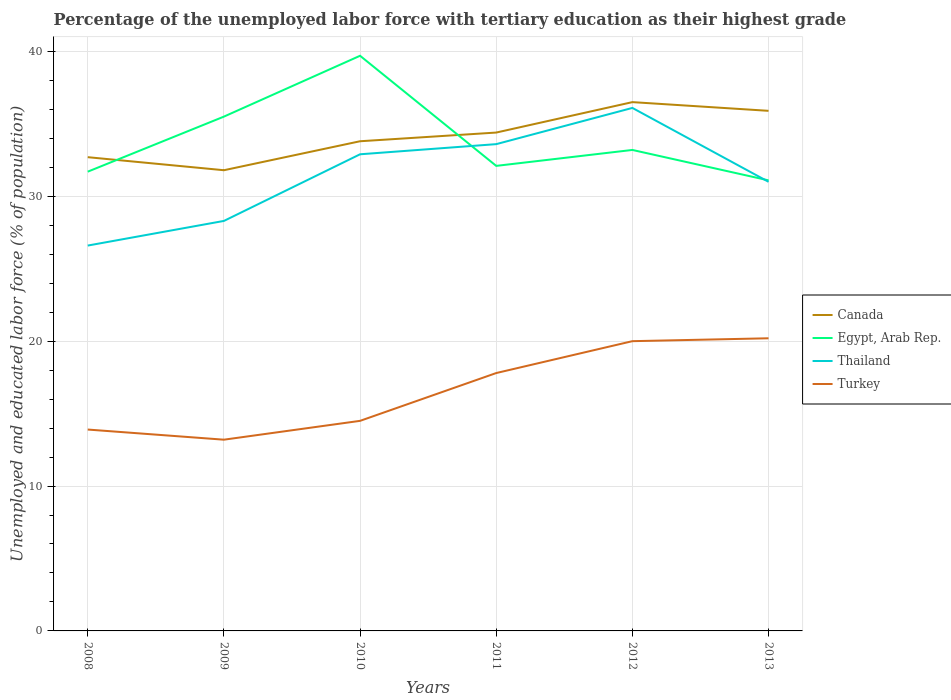How many different coloured lines are there?
Make the answer very short. 4. Across all years, what is the maximum percentage of the unemployed labor force with tertiary education in Thailand?
Give a very brief answer. 26.6. What is the total percentage of the unemployed labor force with tertiary education in Egypt, Arab Rep. in the graph?
Offer a terse response. 2.3. What is the difference between the highest and the second highest percentage of the unemployed labor force with tertiary education in Turkey?
Your answer should be very brief. 7. What is the difference between the highest and the lowest percentage of the unemployed labor force with tertiary education in Canada?
Your answer should be compact. 3. How many years are there in the graph?
Your answer should be compact. 6. What is the difference between two consecutive major ticks on the Y-axis?
Offer a terse response. 10. Are the values on the major ticks of Y-axis written in scientific E-notation?
Your answer should be compact. No. Where does the legend appear in the graph?
Offer a terse response. Center right. How many legend labels are there?
Keep it short and to the point. 4. What is the title of the graph?
Ensure brevity in your answer.  Percentage of the unemployed labor force with tertiary education as their highest grade. Does "Australia" appear as one of the legend labels in the graph?
Give a very brief answer. No. What is the label or title of the Y-axis?
Provide a short and direct response. Unemployed and educated labor force (% of population). What is the Unemployed and educated labor force (% of population) in Canada in 2008?
Provide a succinct answer. 32.7. What is the Unemployed and educated labor force (% of population) of Egypt, Arab Rep. in 2008?
Keep it short and to the point. 31.7. What is the Unemployed and educated labor force (% of population) in Thailand in 2008?
Make the answer very short. 26.6. What is the Unemployed and educated labor force (% of population) of Turkey in 2008?
Offer a terse response. 13.9. What is the Unemployed and educated labor force (% of population) in Canada in 2009?
Provide a succinct answer. 31.8. What is the Unemployed and educated labor force (% of population) of Egypt, Arab Rep. in 2009?
Your answer should be compact. 35.5. What is the Unemployed and educated labor force (% of population) of Thailand in 2009?
Offer a terse response. 28.3. What is the Unemployed and educated labor force (% of population) in Turkey in 2009?
Provide a succinct answer. 13.2. What is the Unemployed and educated labor force (% of population) of Canada in 2010?
Ensure brevity in your answer.  33.8. What is the Unemployed and educated labor force (% of population) of Egypt, Arab Rep. in 2010?
Offer a terse response. 39.7. What is the Unemployed and educated labor force (% of population) in Thailand in 2010?
Provide a succinct answer. 32.9. What is the Unemployed and educated labor force (% of population) in Turkey in 2010?
Your answer should be compact. 14.5. What is the Unemployed and educated labor force (% of population) in Canada in 2011?
Your answer should be very brief. 34.4. What is the Unemployed and educated labor force (% of population) in Egypt, Arab Rep. in 2011?
Keep it short and to the point. 32.1. What is the Unemployed and educated labor force (% of population) of Thailand in 2011?
Make the answer very short. 33.6. What is the Unemployed and educated labor force (% of population) of Turkey in 2011?
Keep it short and to the point. 17.8. What is the Unemployed and educated labor force (% of population) of Canada in 2012?
Make the answer very short. 36.5. What is the Unemployed and educated labor force (% of population) of Egypt, Arab Rep. in 2012?
Offer a very short reply. 33.2. What is the Unemployed and educated labor force (% of population) in Thailand in 2012?
Offer a very short reply. 36.1. What is the Unemployed and educated labor force (% of population) of Turkey in 2012?
Offer a terse response. 20. What is the Unemployed and educated labor force (% of population) in Canada in 2013?
Offer a terse response. 35.9. What is the Unemployed and educated labor force (% of population) of Egypt, Arab Rep. in 2013?
Your response must be concise. 31.1. What is the Unemployed and educated labor force (% of population) of Turkey in 2013?
Ensure brevity in your answer.  20.2. Across all years, what is the maximum Unemployed and educated labor force (% of population) in Canada?
Your answer should be very brief. 36.5. Across all years, what is the maximum Unemployed and educated labor force (% of population) in Egypt, Arab Rep.?
Your answer should be very brief. 39.7. Across all years, what is the maximum Unemployed and educated labor force (% of population) in Thailand?
Your answer should be compact. 36.1. Across all years, what is the maximum Unemployed and educated labor force (% of population) in Turkey?
Provide a short and direct response. 20.2. Across all years, what is the minimum Unemployed and educated labor force (% of population) of Canada?
Provide a short and direct response. 31.8. Across all years, what is the minimum Unemployed and educated labor force (% of population) of Egypt, Arab Rep.?
Keep it short and to the point. 31.1. Across all years, what is the minimum Unemployed and educated labor force (% of population) of Thailand?
Provide a short and direct response. 26.6. Across all years, what is the minimum Unemployed and educated labor force (% of population) of Turkey?
Keep it short and to the point. 13.2. What is the total Unemployed and educated labor force (% of population) of Canada in the graph?
Provide a short and direct response. 205.1. What is the total Unemployed and educated labor force (% of population) in Egypt, Arab Rep. in the graph?
Offer a very short reply. 203.3. What is the total Unemployed and educated labor force (% of population) in Thailand in the graph?
Keep it short and to the point. 188.5. What is the total Unemployed and educated labor force (% of population) of Turkey in the graph?
Offer a very short reply. 99.6. What is the difference between the Unemployed and educated labor force (% of population) of Egypt, Arab Rep. in 2008 and that in 2009?
Keep it short and to the point. -3.8. What is the difference between the Unemployed and educated labor force (% of population) in Canada in 2008 and that in 2010?
Provide a short and direct response. -1.1. What is the difference between the Unemployed and educated labor force (% of population) in Egypt, Arab Rep. in 2008 and that in 2010?
Offer a terse response. -8. What is the difference between the Unemployed and educated labor force (% of population) of Thailand in 2008 and that in 2010?
Your answer should be compact. -6.3. What is the difference between the Unemployed and educated labor force (% of population) in Canada in 2008 and that in 2011?
Your answer should be compact. -1.7. What is the difference between the Unemployed and educated labor force (% of population) of Thailand in 2008 and that in 2011?
Provide a short and direct response. -7. What is the difference between the Unemployed and educated labor force (% of population) in Canada in 2008 and that in 2012?
Give a very brief answer. -3.8. What is the difference between the Unemployed and educated labor force (% of population) in Egypt, Arab Rep. in 2008 and that in 2012?
Your response must be concise. -1.5. What is the difference between the Unemployed and educated labor force (% of population) in Thailand in 2008 and that in 2012?
Ensure brevity in your answer.  -9.5. What is the difference between the Unemployed and educated labor force (% of population) of Turkey in 2008 and that in 2012?
Your answer should be compact. -6.1. What is the difference between the Unemployed and educated labor force (% of population) of Egypt, Arab Rep. in 2008 and that in 2013?
Give a very brief answer. 0.6. What is the difference between the Unemployed and educated labor force (% of population) of Thailand in 2008 and that in 2013?
Provide a succinct answer. -4.4. What is the difference between the Unemployed and educated labor force (% of population) in Canada in 2009 and that in 2010?
Make the answer very short. -2. What is the difference between the Unemployed and educated labor force (% of population) of Egypt, Arab Rep. in 2009 and that in 2010?
Make the answer very short. -4.2. What is the difference between the Unemployed and educated labor force (% of population) of Thailand in 2009 and that in 2010?
Your answer should be very brief. -4.6. What is the difference between the Unemployed and educated labor force (% of population) in Egypt, Arab Rep. in 2009 and that in 2011?
Provide a short and direct response. 3.4. What is the difference between the Unemployed and educated labor force (% of population) of Egypt, Arab Rep. in 2009 and that in 2012?
Ensure brevity in your answer.  2.3. What is the difference between the Unemployed and educated labor force (% of population) of Thailand in 2009 and that in 2012?
Provide a short and direct response. -7.8. What is the difference between the Unemployed and educated labor force (% of population) of Canada in 2009 and that in 2013?
Provide a succinct answer. -4.1. What is the difference between the Unemployed and educated labor force (% of population) of Egypt, Arab Rep. in 2009 and that in 2013?
Ensure brevity in your answer.  4.4. What is the difference between the Unemployed and educated labor force (% of population) of Thailand in 2009 and that in 2013?
Your answer should be very brief. -2.7. What is the difference between the Unemployed and educated labor force (% of population) of Canada in 2010 and that in 2011?
Your answer should be very brief. -0.6. What is the difference between the Unemployed and educated labor force (% of population) of Thailand in 2010 and that in 2011?
Your answer should be compact. -0.7. What is the difference between the Unemployed and educated labor force (% of population) of Canada in 2010 and that in 2012?
Keep it short and to the point. -2.7. What is the difference between the Unemployed and educated labor force (% of population) of Egypt, Arab Rep. in 2010 and that in 2012?
Provide a short and direct response. 6.5. What is the difference between the Unemployed and educated labor force (% of population) in Thailand in 2010 and that in 2012?
Make the answer very short. -3.2. What is the difference between the Unemployed and educated labor force (% of population) in Egypt, Arab Rep. in 2010 and that in 2013?
Make the answer very short. 8.6. What is the difference between the Unemployed and educated labor force (% of population) in Thailand in 2010 and that in 2013?
Your answer should be compact. 1.9. What is the difference between the Unemployed and educated labor force (% of population) in Turkey in 2010 and that in 2013?
Ensure brevity in your answer.  -5.7. What is the difference between the Unemployed and educated labor force (% of population) in Egypt, Arab Rep. in 2011 and that in 2012?
Give a very brief answer. -1.1. What is the difference between the Unemployed and educated labor force (% of population) in Canada in 2011 and that in 2013?
Offer a very short reply. -1.5. What is the difference between the Unemployed and educated labor force (% of population) in Egypt, Arab Rep. in 2011 and that in 2013?
Provide a short and direct response. 1. What is the difference between the Unemployed and educated labor force (% of population) of Thailand in 2011 and that in 2013?
Offer a terse response. 2.6. What is the difference between the Unemployed and educated labor force (% of population) in Turkey in 2011 and that in 2013?
Your answer should be very brief. -2.4. What is the difference between the Unemployed and educated labor force (% of population) in Canada in 2012 and that in 2013?
Make the answer very short. 0.6. What is the difference between the Unemployed and educated labor force (% of population) of Thailand in 2012 and that in 2013?
Your response must be concise. 5.1. What is the difference between the Unemployed and educated labor force (% of population) in Canada in 2008 and the Unemployed and educated labor force (% of population) in Thailand in 2009?
Ensure brevity in your answer.  4.4. What is the difference between the Unemployed and educated labor force (% of population) of Canada in 2008 and the Unemployed and educated labor force (% of population) of Turkey in 2009?
Your response must be concise. 19.5. What is the difference between the Unemployed and educated labor force (% of population) in Egypt, Arab Rep. in 2008 and the Unemployed and educated labor force (% of population) in Thailand in 2009?
Offer a terse response. 3.4. What is the difference between the Unemployed and educated labor force (% of population) of Egypt, Arab Rep. in 2008 and the Unemployed and educated labor force (% of population) of Turkey in 2009?
Provide a succinct answer. 18.5. What is the difference between the Unemployed and educated labor force (% of population) of Thailand in 2008 and the Unemployed and educated labor force (% of population) of Turkey in 2009?
Your answer should be very brief. 13.4. What is the difference between the Unemployed and educated labor force (% of population) of Canada in 2008 and the Unemployed and educated labor force (% of population) of Thailand in 2010?
Offer a very short reply. -0.2. What is the difference between the Unemployed and educated labor force (% of population) in Canada in 2008 and the Unemployed and educated labor force (% of population) in Turkey in 2010?
Provide a succinct answer. 18.2. What is the difference between the Unemployed and educated labor force (% of population) in Egypt, Arab Rep. in 2008 and the Unemployed and educated labor force (% of population) in Thailand in 2010?
Your answer should be very brief. -1.2. What is the difference between the Unemployed and educated labor force (% of population) in Canada in 2008 and the Unemployed and educated labor force (% of population) in Turkey in 2011?
Make the answer very short. 14.9. What is the difference between the Unemployed and educated labor force (% of population) of Egypt, Arab Rep. in 2008 and the Unemployed and educated labor force (% of population) of Thailand in 2011?
Offer a terse response. -1.9. What is the difference between the Unemployed and educated labor force (% of population) of Canada in 2008 and the Unemployed and educated labor force (% of population) of Thailand in 2012?
Provide a short and direct response. -3.4. What is the difference between the Unemployed and educated labor force (% of population) of Canada in 2008 and the Unemployed and educated labor force (% of population) of Turkey in 2012?
Offer a terse response. 12.7. What is the difference between the Unemployed and educated labor force (% of population) in Egypt, Arab Rep. in 2008 and the Unemployed and educated labor force (% of population) in Thailand in 2012?
Offer a very short reply. -4.4. What is the difference between the Unemployed and educated labor force (% of population) in Egypt, Arab Rep. in 2008 and the Unemployed and educated labor force (% of population) in Turkey in 2012?
Your answer should be compact. 11.7. What is the difference between the Unemployed and educated labor force (% of population) in Thailand in 2008 and the Unemployed and educated labor force (% of population) in Turkey in 2012?
Make the answer very short. 6.6. What is the difference between the Unemployed and educated labor force (% of population) of Thailand in 2008 and the Unemployed and educated labor force (% of population) of Turkey in 2013?
Make the answer very short. 6.4. What is the difference between the Unemployed and educated labor force (% of population) of Canada in 2009 and the Unemployed and educated labor force (% of population) of Turkey in 2010?
Ensure brevity in your answer.  17.3. What is the difference between the Unemployed and educated labor force (% of population) in Thailand in 2009 and the Unemployed and educated labor force (% of population) in Turkey in 2010?
Offer a very short reply. 13.8. What is the difference between the Unemployed and educated labor force (% of population) in Canada in 2009 and the Unemployed and educated labor force (% of population) in Egypt, Arab Rep. in 2011?
Your response must be concise. -0.3. What is the difference between the Unemployed and educated labor force (% of population) in Canada in 2009 and the Unemployed and educated labor force (% of population) in Thailand in 2011?
Offer a terse response. -1.8. What is the difference between the Unemployed and educated labor force (% of population) in Egypt, Arab Rep. in 2009 and the Unemployed and educated labor force (% of population) in Turkey in 2011?
Keep it short and to the point. 17.7. What is the difference between the Unemployed and educated labor force (% of population) of Canada in 2009 and the Unemployed and educated labor force (% of population) of Thailand in 2013?
Your answer should be very brief. 0.8. What is the difference between the Unemployed and educated labor force (% of population) of Canada in 2009 and the Unemployed and educated labor force (% of population) of Turkey in 2013?
Your response must be concise. 11.6. What is the difference between the Unemployed and educated labor force (% of population) in Egypt, Arab Rep. in 2009 and the Unemployed and educated labor force (% of population) in Thailand in 2013?
Your response must be concise. 4.5. What is the difference between the Unemployed and educated labor force (% of population) in Egypt, Arab Rep. in 2009 and the Unemployed and educated labor force (% of population) in Turkey in 2013?
Your answer should be very brief. 15.3. What is the difference between the Unemployed and educated labor force (% of population) of Thailand in 2009 and the Unemployed and educated labor force (% of population) of Turkey in 2013?
Give a very brief answer. 8.1. What is the difference between the Unemployed and educated labor force (% of population) of Egypt, Arab Rep. in 2010 and the Unemployed and educated labor force (% of population) of Thailand in 2011?
Offer a terse response. 6.1. What is the difference between the Unemployed and educated labor force (% of population) in Egypt, Arab Rep. in 2010 and the Unemployed and educated labor force (% of population) in Turkey in 2011?
Ensure brevity in your answer.  21.9. What is the difference between the Unemployed and educated labor force (% of population) of Thailand in 2010 and the Unemployed and educated labor force (% of population) of Turkey in 2011?
Provide a short and direct response. 15.1. What is the difference between the Unemployed and educated labor force (% of population) in Canada in 2010 and the Unemployed and educated labor force (% of population) in Thailand in 2012?
Provide a short and direct response. -2.3. What is the difference between the Unemployed and educated labor force (% of population) of Canada in 2010 and the Unemployed and educated labor force (% of population) of Turkey in 2012?
Make the answer very short. 13.8. What is the difference between the Unemployed and educated labor force (% of population) in Egypt, Arab Rep. in 2010 and the Unemployed and educated labor force (% of population) in Thailand in 2012?
Your response must be concise. 3.6. What is the difference between the Unemployed and educated labor force (% of population) of Thailand in 2010 and the Unemployed and educated labor force (% of population) of Turkey in 2012?
Keep it short and to the point. 12.9. What is the difference between the Unemployed and educated labor force (% of population) in Canada in 2010 and the Unemployed and educated labor force (% of population) in Thailand in 2013?
Provide a short and direct response. 2.8. What is the difference between the Unemployed and educated labor force (% of population) in Egypt, Arab Rep. in 2010 and the Unemployed and educated labor force (% of population) in Turkey in 2013?
Offer a very short reply. 19.5. What is the difference between the Unemployed and educated labor force (% of population) of Thailand in 2010 and the Unemployed and educated labor force (% of population) of Turkey in 2013?
Make the answer very short. 12.7. What is the difference between the Unemployed and educated labor force (% of population) in Canada in 2011 and the Unemployed and educated labor force (% of population) in Turkey in 2012?
Ensure brevity in your answer.  14.4. What is the difference between the Unemployed and educated labor force (% of population) of Egypt, Arab Rep. in 2011 and the Unemployed and educated labor force (% of population) of Thailand in 2012?
Offer a very short reply. -4. What is the difference between the Unemployed and educated labor force (% of population) of Thailand in 2011 and the Unemployed and educated labor force (% of population) of Turkey in 2012?
Make the answer very short. 13.6. What is the difference between the Unemployed and educated labor force (% of population) in Canada in 2011 and the Unemployed and educated labor force (% of population) in Egypt, Arab Rep. in 2013?
Make the answer very short. 3.3. What is the difference between the Unemployed and educated labor force (% of population) in Canada in 2011 and the Unemployed and educated labor force (% of population) in Turkey in 2013?
Provide a succinct answer. 14.2. What is the difference between the Unemployed and educated labor force (% of population) in Egypt, Arab Rep. in 2011 and the Unemployed and educated labor force (% of population) in Thailand in 2013?
Offer a terse response. 1.1. What is the difference between the Unemployed and educated labor force (% of population) in Egypt, Arab Rep. in 2011 and the Unemployed and educated labor force (% of population) in Turkey in 2013?
Offer a terse response. 11.9. What is the difference between the Unemployed and educated labor force (% of population) of Egypt, Arab Rep. in 2012 and the Unemployed and educated labor force (% of population) of Thailand in 2013?
Provide a succinct answer. 2.2. What is the difference between the Unemployed and educated labor force (% of population) of Thailand in 2012 and the Unemployed and educated labor force (% of population) of Turkey in 2013?
Keep it short and to the point. 15.9. What is the average Unemployed and educated labor force (% of population) of Canada per year?
Your response must be concise. 34.18. What is the average Unemployed and educated labor force (% of population) in Egypt, Arab Rep. per year?
Your answer should be compact. 33.88. What is the average Unemployed and educated labor force (% of population) of Thailand per year?
Offer a very short reply. 31.42. What is the average Unemployed and educated labor force (% of population) of Turkey per year?
Make the answer very short. 16.6. In the year 2008, what is the difference between the Unemployed and educated labor force (% of population) in Canada and Unemployed and educated labor force (% of population) in Egypt, Arab Rep.?
Make the answer very short. 1. In the year 2008, what is the difference between the Unemployed and educated labor force (% of population) in Egypt, Arab Rep. and Unemployed and educated labor force (% of population) in Thailand?
Your answer should be very brief. 5.1. In the year 2008, what is the difference between the Unemployed and educated labor force (% of population) of Thailand and Unemployed and educated labor force (% of population) of Turkey?
Make the answer very short. 12.7. In the year 2009, what is the difference between the Unemployed and educated labor force (% of population) in Canada and Unemployed and educated labor force (% of population) in Turkey?
Make the answer very short. 18.6. In the year 2009, what is the difference between the Unemployed and educated labor force (% of population) of Egypt, Arab Rep. and Unemployed and educated labor force (% of population) of Turkey?
Your answer should be very brief. 22.3. In the year 2010, what is the difference between the Unemployed and educated labor force (% of population) in Canada and Unemployed and educated labor force (% of population) in Turkey?
Make the answer very short. 19.3. In the year 2010, what is the difference between the Unemployed and educated labor force (% of population) in Egypt, Arab Rep. and Unemployed and educated labor force (% of population) in Thailand?
Make the answer very short. 6.8. In the year 2010, what is the difference between the Unemployed and educated labor force (% of population) of Egypt, Arab Rep. and Unemployed and educated labor force (% of population) of Turkey?
Give a very brief answer. 25.2. In the year 2011, what is the difference between the Unemployed and educated labor force (% of population) in Canada and Unemployed and educated labor force (% of population) in Egypt, Arab Rep.?
Your response must be concise. 2.3. In the year 2011, what is the difference between the Unemployed and educated labor force (% of population) of Egypt, Arab Rep. and Unemployed and educated labor force (% of population) of Turkey?
Your answer should be very brief. 14.3. In the year 2012, what is the difference between the Unemployed and educated labor force (% of population) of Canada and Unemployed and educated labor force (% of population) of Thailand?
Make the answer very short. 0.4. In the year 2012, what is the difference between the Unemployed and educated labor force (% of population) in Canada and Unemployed and educated labor force (% of population) in Turkey?
Your answer should be compact. 16.5. In the year 2012, what is the difference between the Unemployed and educated labor force (% of population) of Egypt, Arab Rep. and Unemployed and educated labor force (% of population) of Thailand?
Provide a succinct answer. -2.9. In the year 2013, what is the difference between the Unemployed and educated labor force (% of population) in Canada and Unemployed and educated labor force (% of population) in Egypt, Arab Rep.?
Your answer should be compact. 4.8. In the year 2013, what is the difference between the Unemployed and educated labor force (% of population) of Egypt, Arab Rep. and Unemployed and educated labor force (% of population) of Turkey?
Provide a short and direct response. 10.9. What is the ratio of the Unemployed and educated labor force (% of population) in Canada in 2008 to that in 2009?
Make the answer very short. 1.03. What is the ratio of the Unemployed and educated labor force (% of population) of Egypt, Arab Rep. in 2008 to that in 2009?
Make the answer very short. 0.89. What is the ratio of the Unemployed and educated labor force (% of population) in Thailand in 2008 to that in 2009?
Ensure brevity in your answer.  0.94. What is the ratio of the Unemployed and educated labor force (% of population) of Turkey in 2008 to that in 2009?
Your response must be concise. 1.05. What is the ratio of the Unemployed and educated labor force (% of population) of Canada in 2008 to that in 2010?
Offer a terse response. 0.97. What is the ratio of the Unemployed and educated labor force (% of population) in Egypt, Arab Rep. in 2008 to that in 2010?
Offer a very short reply. 0.8. What is the ratio of the Unemployed and educated labor force (% of population) of Thailand in 2008 to that in 2010?
Your answer should be very brief. 0.81. What is the ratio of the Unemployed and educated labor force (% of population) in Turkey in 2008 to that in 2010?
Offer a terse response. 0.96. What is the ratio of the Unemployed and educated labor force (% of population) of Canada in 2008 to that in 2011?
Offer a terse response. 0.95. What is the ratio of the Unemployed and educated labor force (% of population) in Egypt, Arab Rep. in 2008 to that in 2011?
Your answer should be compact. 0.99. What is the ratio of the Unemployed and educated labor force (% of population) of Thailand in 2008 to that in 2011?
Provide a short and direct response. 0.79. What is the ratio of the Unemployed and educated labor force (% of population) in Turkey in 2008 to that in 2011?
Ensure brevity in your answer.  0.78. What is the ratio of the Unemployed and educated labor force (% of population) in Canada in 2008 to that in 2012?
Your answer should be compact. 0.9. What is the ratio of the Unemployed and educated labor force (% of population) of Egypt, Arab Rep. in 2008 to that in 2012?
Your answer should be very brief. 0.95. What is the ratio of the Unemployed and educated labor force (% of population) of Thailand in 2008 to that in 2012?
Keep it short and to the point. 0.74. What is the ratio of the Unemployed and educated labor force (% of population) of Turkey in 2008 to that in 2012?
Offer a terse response. 0.69. What is the ratio of the Unemployed and educated labor force (% of population) in Canada in 2008 to that in 2013?
Offer a terse response. 0.91. What is the ratio of the Unemployed and educated labor force (% of population) in Egypt, Arab Rep. in 2008 to that in 2013?
Make the answer very short. 1.02. What is the ratio of the Unemployed and educated labor force (% of population) of Thailand in 2008 to that in 2013?
Your response must be concise. 0.86. What is the ratio of the Unemployed and educated labor force (% of population) of Turkey in 2008 to that in 2013?
Your answer should be compact. 0.69. What is the ratio of the Unemployed and educated labor force (% of population) in Canada in 2009 to that in 2010?
Provide a short and direct response. 0.94. What is the ratio of the Unemployed and educated labor force (% of population) of Egypt, Arab Rep. in 2009 to that in 2010?
Provide a short and direct response. 0.89. What is the ratio of the Unemployed and educated labor force (% of population) in Thailand in 2009 to that in 2010?
Offer a very short reply. 0.86. What is the ratio of the Unemployed and educated labor force (% of population) of Turkey in 2009 to that in 2010?
Offer a very short reply. 0.91. What is the ratio of the Unemployed and educated labor force (% of population) in Canada in 2009 to that in 2011?
Offer a very short reply. 0.92. What is the ratio of the Unemployed and educated labor force (% of population) of Egypt, Arab Rep. in 2009 to that in 2011?
Give a very brief answer. 1.11. What is the ratio of the Unemployed and educated labor force (% of population) of Thailand in 2009 to that in 2011?
Your response must be concise. 0.84. What is the ratio of the Unemployed and educated labor force (% of population) of Turkey in 2009 to that in 2011?
Your response must be concise. 0.74. What is the ratio of the Unemployed and educated labor force (% of population) of Canada in 2009 to that in 2012?
Your answer should be very brief. 0.87. What is the ratio of the Unemployed and educated labor force (% of population) of Egypt, Arab Rep. in 2009 to that in 2012?
Provide a succinct answer. 1.07. What is the ratio of the Unemployed and educated labor force (% of population) in Thailand in 2009 to that in 2012?
Your answer should be compact. 0.78. What is the ratio of the Unemployed and educated labor force (% of population) of Turkey in 2009 to that in 2012?
Ensure brevity in your answer.  0.66. What is the ratio of the Unemployed and educated labor force (% of population) of Canada in 2009 to that in 2013?
Ensure brevity in your answer.  0.89. What is the ratio of the Unemployed and educated labor force (% of population) in Egypt, Arab Rep. in 2009 to that in 2013?
Offer a very short reply. 1.14. What is the ratio of the Unemployed and educated labor force (% of population) in Thailand in 2009 to that in 2013?
Offer a terse response. 0.91. What is the ratio of the Unemployed and educated labor force (% of population) in Turkey in 2009 to that in 2013?
Give a very brief answer. 0.65. What is the ratio of the Unemployed and educated labor force (% of population) of Canada in 2010 to that in 2011?
Provide a succinct answer. 0.98. What is the ratio of the Unemployed and educated labor force (% of population) of Egypt, Arab Rep. in 2010 to that in 2011?
Offer a terse response. 1.24. What is the ratio of the Unemployed and educated labor force (% of population) of Thailand in 2010 to that in 2011?
Offer a terse response. 0.98. What is the ratio of the Unemployed and educated labor force (% of population) of Turkey in 2010 to that in 2011?
Keep it short and to the point. 0.81. What is the ratio of the Unemployed and educated labor force (% of population) in Canada in 2010 to that in 2012?
Ensure brevity in your answer.  0.93. What is the ratio of the Unemployed and educated labor force (% of population) of Egypt, Arab Rep. in 2010 to that in 2012?
Ensure brevity in your answer.  1.2. What is the ratio of the Unemployed and educated labor force (% of population) of Thailand in 2010 to that in 2012?
Provide a succinct answer. 0.91. What is the ratio of the Unemployed and educated labor force (% of population) in Turkey in 2010 to that in 2012?
Offer a very short reply. 0.72. What is the ratio of the Unemployed and educated labor force (% of population) in Canada in 2010 to that in 2013?
Give a very brief answer. 0.94. What is the ratio of the Unemployed and educated labor force (% of population) of Egypt, Arab Rep. in 2010 to that in 2013?
Keep it short and to the point. 1.28. What is the ratio of the Unemployed and educated labor force (% of population) in Thailand in 2010 to that in 2013?
Provide a short and direct response. 1.06. What is the ratio of the Unemployed and educated labor force (% of population) of Turkey in 2010 to that in 2013?
Keep it short and to the point. 0.72. What is the ratio of the Unemployed and educated labor force (% of population) in Canada in 2011 to that in 2012?
Your response must be concise. 0.94. What is the ratio of the Unemployed and educated labor force (% of population) of Egypt, Arab Rep. in 2011 to that in 2012?
Give a very brief answer. 0.97. What is the ratio of the Unemployed and educated labor force (% of population) in Thailand in 2011 to that in 2012?
Give a very brief answer. 0.93. What is the ratio of the Unemployed and educated labor force (% of population) in Turkey in 2011 to that in 2012?
Provide a short and direct response. 0.89. What is the ratio of the Unemployed and educated labor force (% of population) in Canada in 2011 to that in 2013?
Your answer should be very brief. 0.96. What is the ratio of the Unemployed and educated labor force (% of population) of Egypt, Arab Rep. in 2011 to that in 2013?
Make the answer very short. 1.03. What is the ratio of the Unemployed and educated labor force (% of population) in Thailand in 2011 to that in 2013?
Give a very brief answer. 1.08. What is the ratio of the Unemployed and educated labor force (% of population) in Turkey in 2011 to that in 2013?
Make the answer very short. 0.88. What is the ratio of the Unemployed and educated labor force (% of population) in Canada in 2012 to that in 2013?
Your answer should be very brief. 1.02. What is the ratio of the Unemployed and educated labor force (% of population) in Egypt, Arab Rep. in 2012 to that in 2013?
Your answer should be very brief. 1.07. What is the ratio of the Unemployed and educated labor force (% of population) of Thailand in 2012 to that in 2013?
Keep it short and to the point. 1.16. What is the difference between the highest and the second highest Unemployed and educated labor force (% of population) of Canada?
Your answer should be very brief. 0.6. What is the difference between the highest and the second highest Unemployed and educated labor force (% of population) in Egypt, Arab Rep.?
Your response must be concise. 4.2. What is the difference between the highest and the second highest Unemployed and educated labor force (% of population) in Thailand?
Provide a succinct answer. 2.5. What is the difference between the highest and the second highest Unemployed and educated labor force (% of population) of Turkey?
Your answer should be very brief. 0.2. What is the difference between the highest and the lowest Unemployed and educated labor force (% of population) in Canada?
Give a very brief answer. 4.7. What is the difference between the highest and the lowest Unemployed and educated labor force (% of population) of Thailand?
Your answer should be compact. 9.5. 